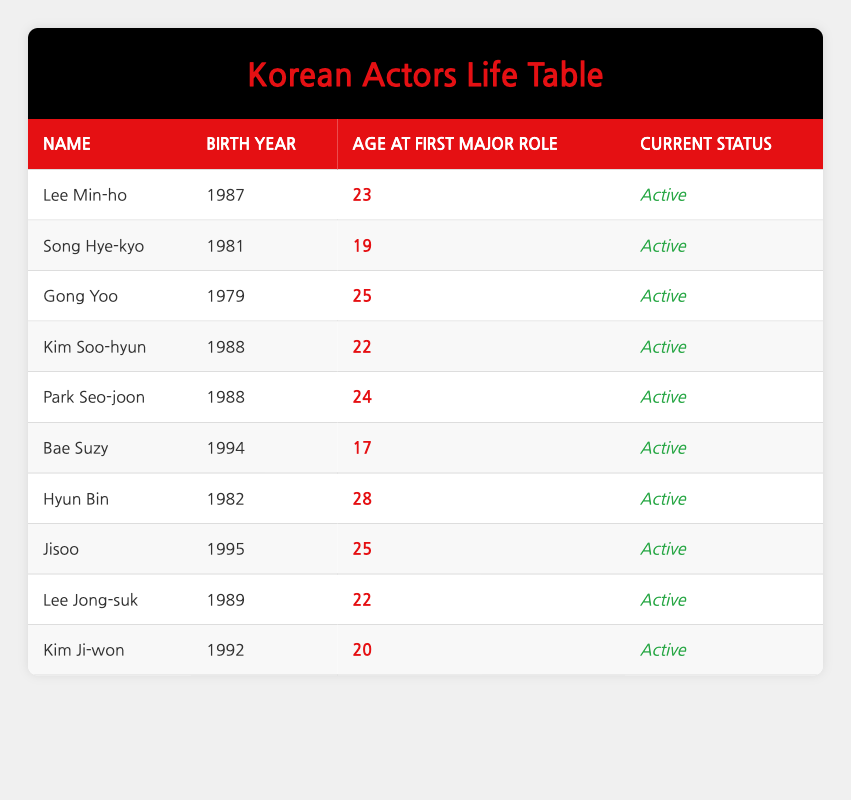What is the name of the actor who had their first major role at the age of 19? The table lists the actors along with their age at their first major role. Scanning through the age column, I find that Song Hye-kyo is associated with the age of 19.
Answer: Song Hye-kyo Which actor debuted at age 24 and was born in 1988? From the table, I check the entries and see that Park Seo-joon was born in 1988 and had his first major role at the age of 24.
Answer: Park Seo-joon How many actors were 22 years old when they had their first major role? I look at the age column and identify the actors who had their first major role at the age of 22. Both Kim Soo-hyun and Lee Jong-suk fit this criterion, so I count them, resulting in a total of two actors.
Answer: 2 Is there any actor in the table born after 1994? By inspecting the birth year column, I can see the actors listed. The most recent birth year listed is 1994 (Bae Suzy) and Jisoo, born in 1995, confirms that there is indeed an actor born after 1994.
Answer: Yes What is the average age at which the actors had their first major role? To find the average age of first major roles, I will sum the ages (23 + 19 + 25 + 22 + 24 + 17 + 28 + 25 + 22 + 20 =  235) then divide by the number of actors (10). Therefore, the average age at first major role is 235 / 10 = 23.5.
Answer: 23.5 